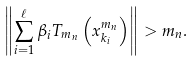Convert formula to latex. <formula><loc_0><loc_0><loc_500><loc_500>\left \| \sum _ { i = 1 } ^ { \ell } \beta _ { i } T _ { m _ { n } } \left ( x _ { k _ { i } } ^ { m _ { n } } \right ) \right \| > m _ { n } .</formula> 